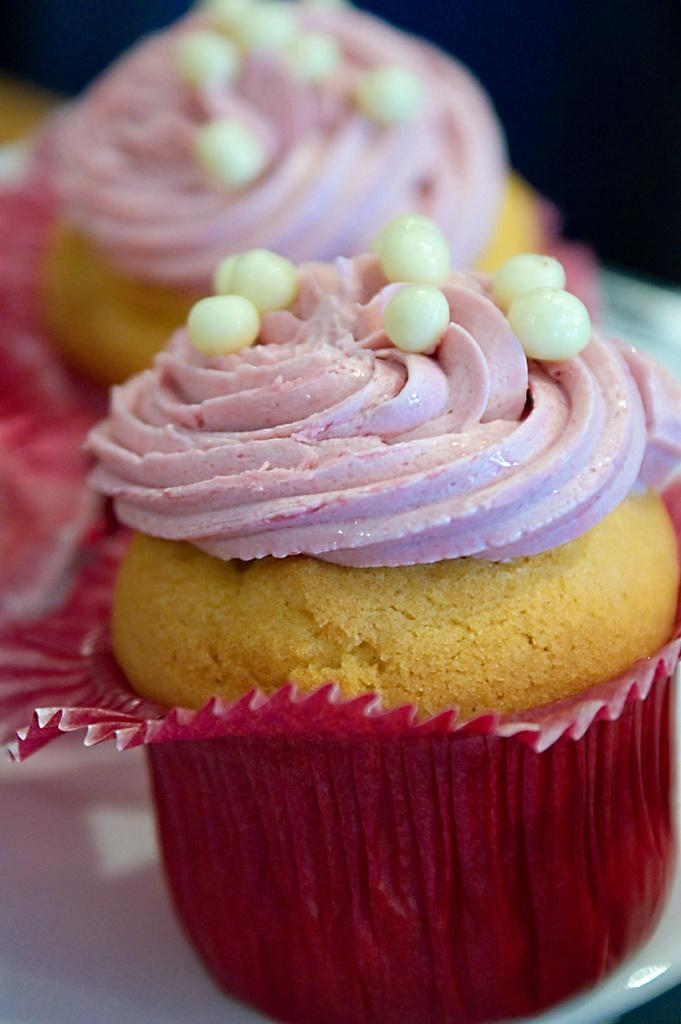What is the color of the plate in the image? The plate in the image is white. What type of food is on the plate? There are cupcakes on the plate. How many bridges can be seen crossing the river in the image? There is no river or bridge present in the image; it only features a white color plate with cupcakes on it. 